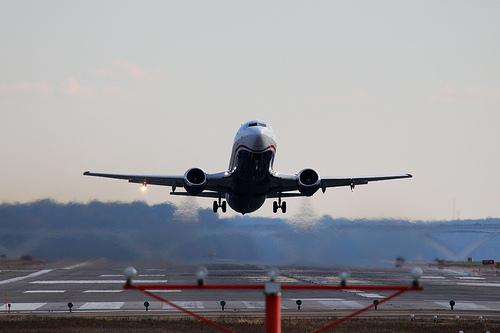Question: what is in the background?
Choices:
A. The hills.
B. Trees.
C. Parking lot.
D. Water.
Answer with the letter. Answer: A Question: what is the plane doing?
Choices:
A. Sitting on the runway.
B. Getting ready to fly away.
C. Flying.
D. Landing.
Answer with the letter. Answer: B Question: who is on the plane?
Choices:
A. The President.
B. Passengers.
C. The pilot.
D. Tourists.
Answer with the letter. Answer: B Question: when was the photo taken?
Choices:
A. 1989.
B. Christmas day.
C. After they got married.
D. During the day.
Answer with the letter. Answer: D 